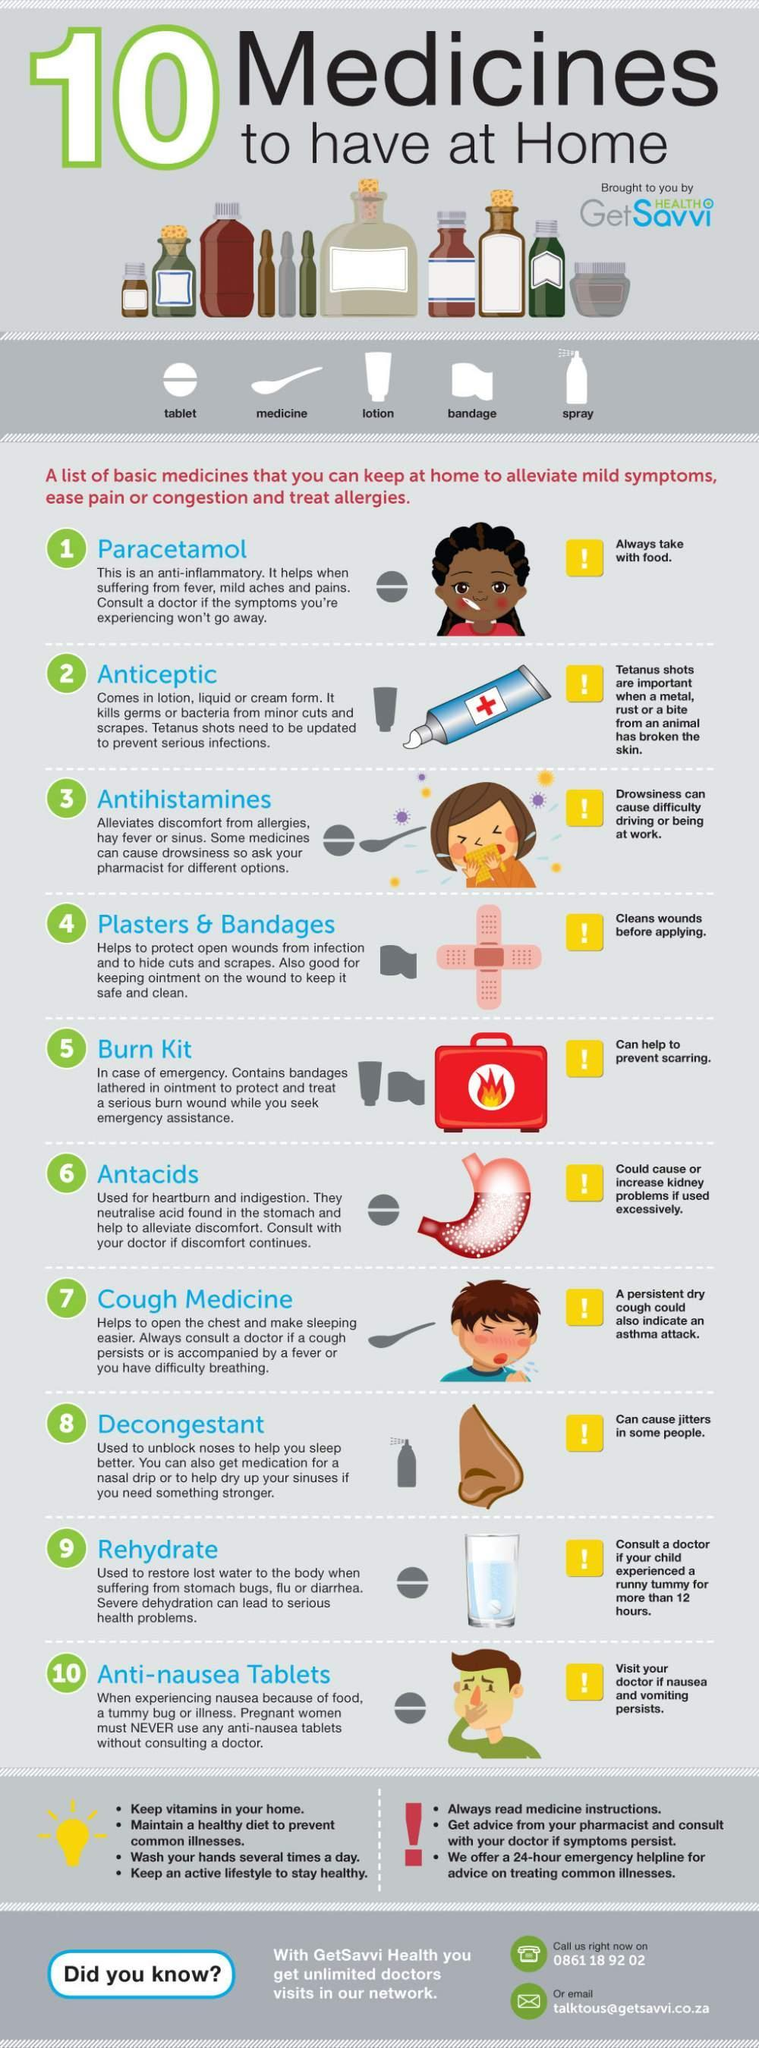WHat is the tube with the + sign on it?
Answer the question with a short phrase. Anticeptic What is the colour of the burn kit, red or blue red Which type of medication could cause or increase kidney problems if used excessively? Antacids What can help to prevent scarring burn kit What should be always taken with food paracetamol What is the side effect of decongestants? Can cause jitters in some people. 